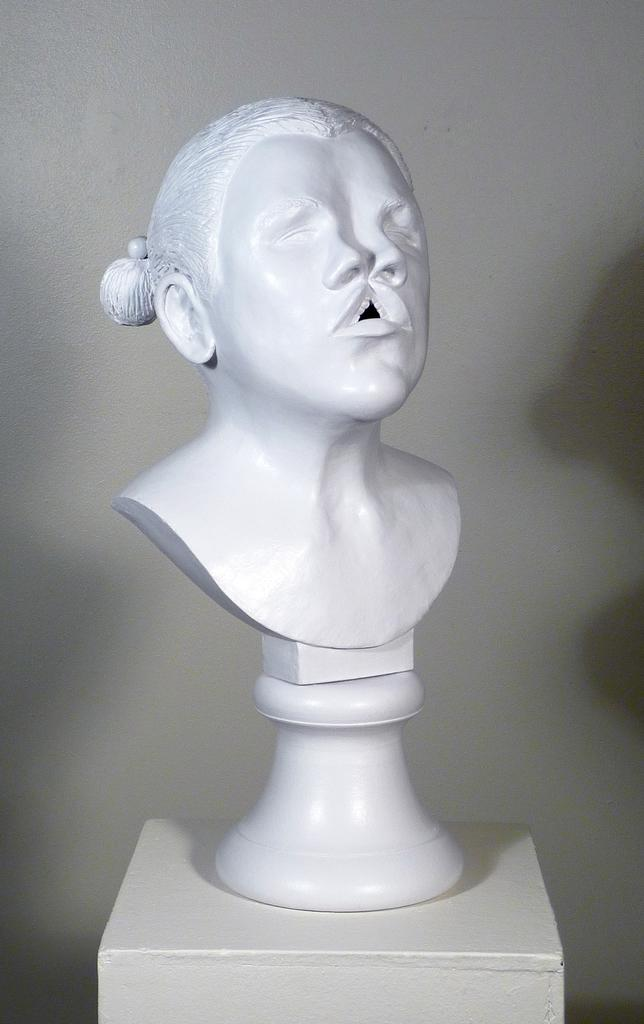What is the main subject of the image? There is a sculpture in the image. What type of fuel is being used by the ring in the image? There is no ring present in the image, and therefore no fuel can be associated with it. 